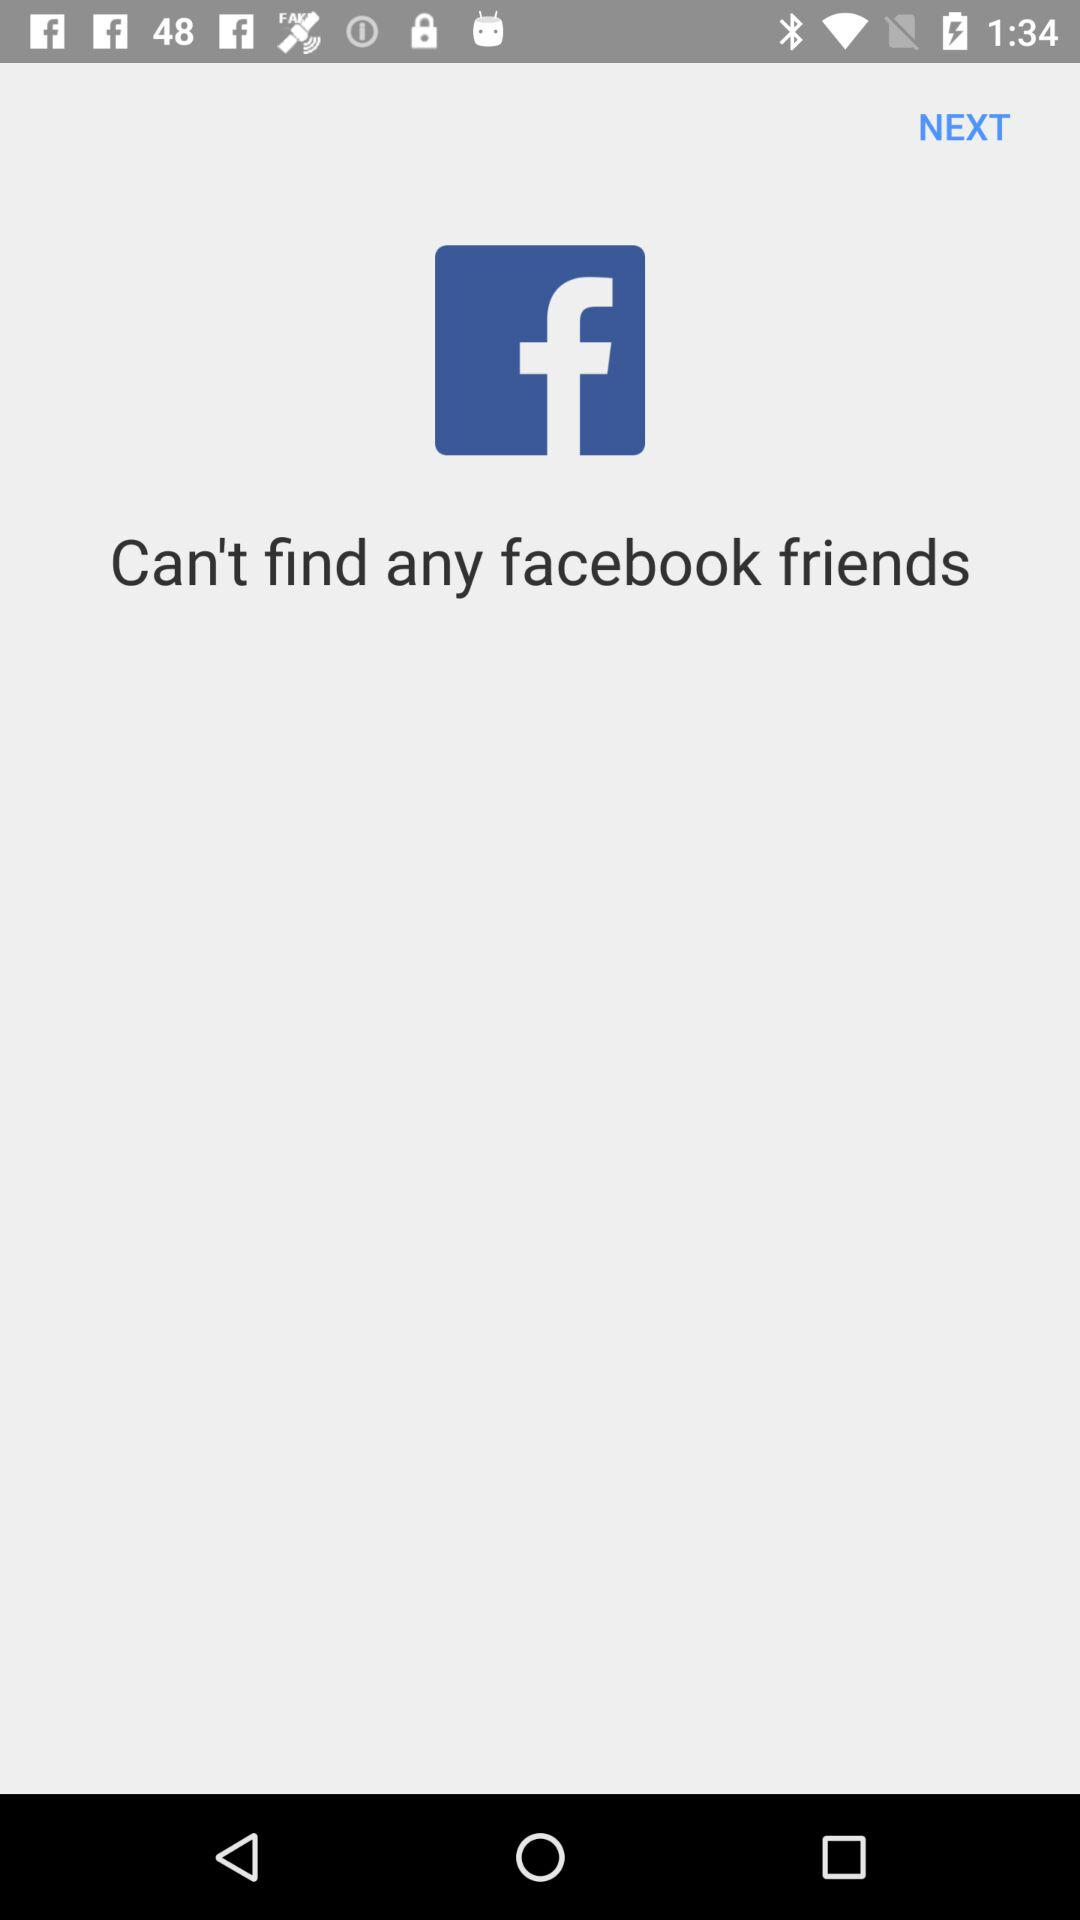What is the name of the application? The name of the application is "facebook". 